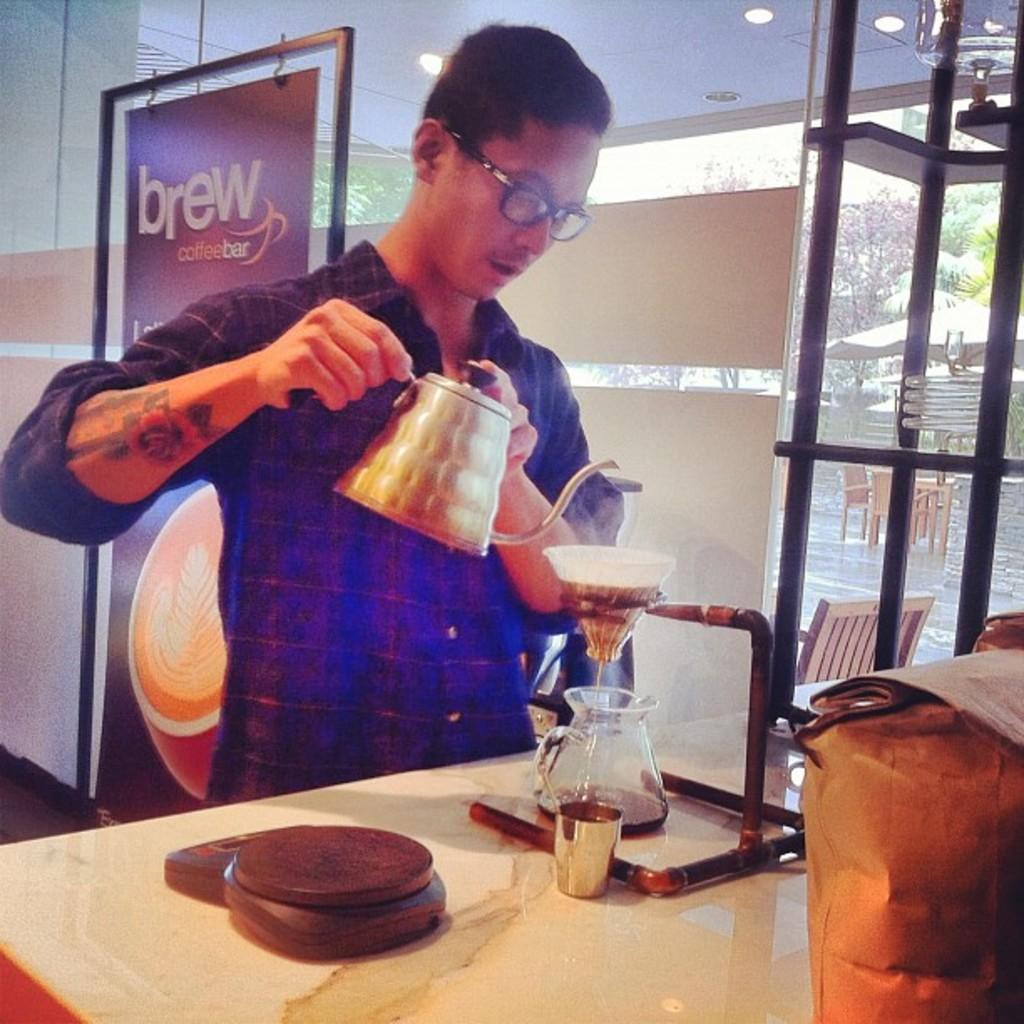Who is present in the image? There is a man in the image. What is the man doing in the image? The man is standing on the floor and holding a jar with his hands. What else can be seen in the image besides the man? There is a glass, lights, and a frame in the image. What type of robin can be seen in the image? There is no robin present in the image. What kind of experience does the man have with the jar in the image? The image does not provide any information about the man's experience with the jar. 